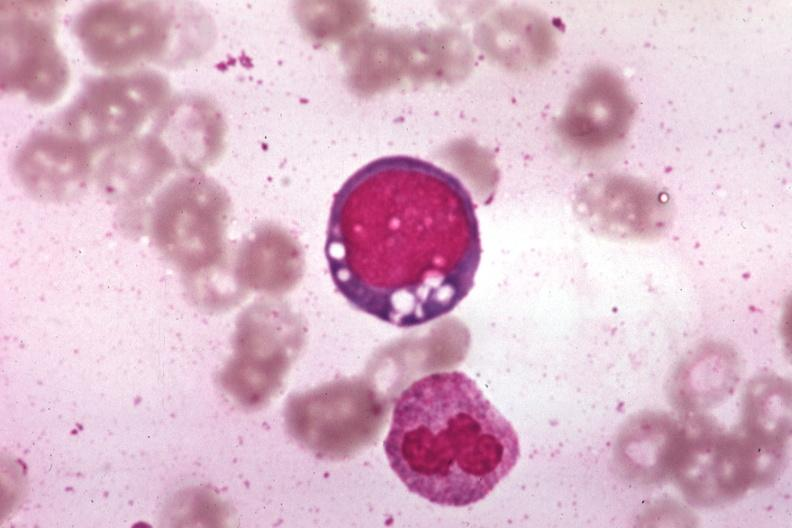s chloramphenicol toxicity present?
Answer the question using a single word or phrase. Yes 